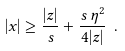<formula> <loc_0><loc_0><loc_500><loc_500>| x | \geq \frac { | z | } { s } + \frac { s \, \eta ^ { 2 } } { 4 | z | } \ .</formula> 